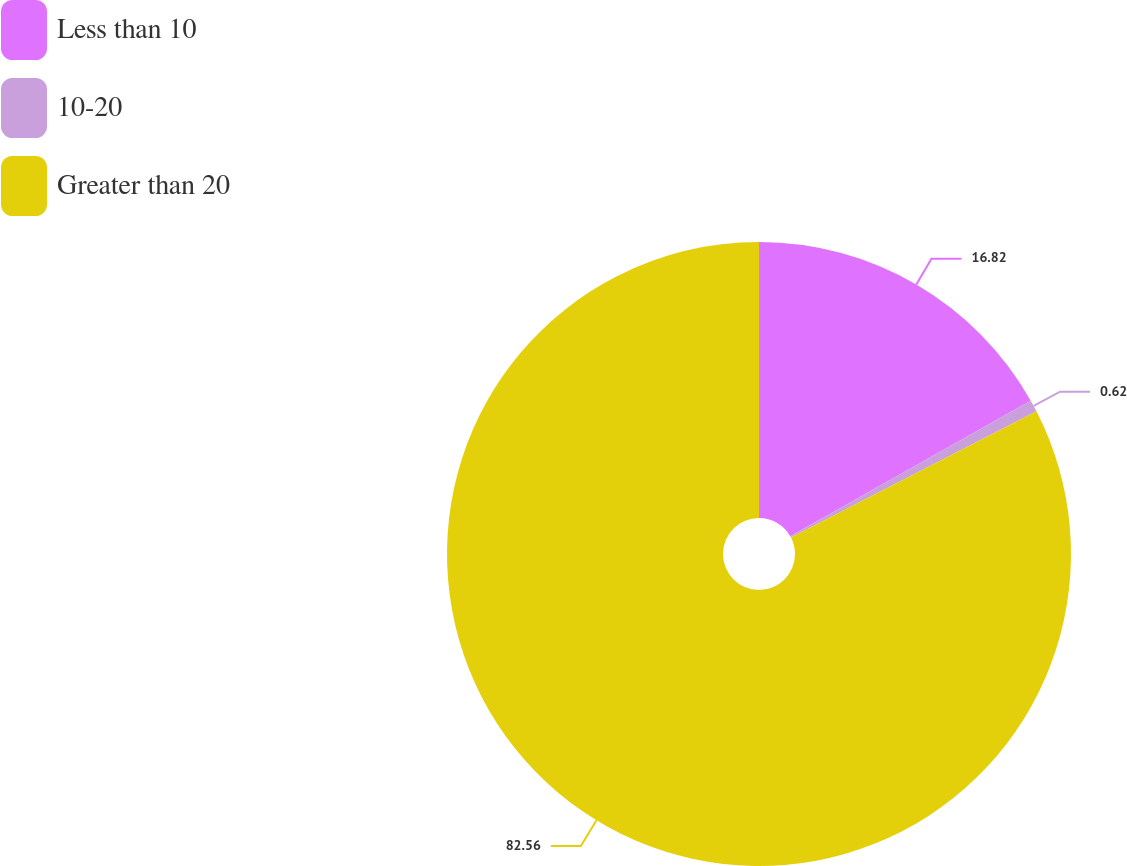<chart> <loc_0><loc_0><loc_500><loc_500><pie_chart><fcel>Less than 10<fcel>10-20<fcel>Greater than 20<nl><fcel>16.82%<fcel>0.62%<fcel>82.55%<nl></chart> 